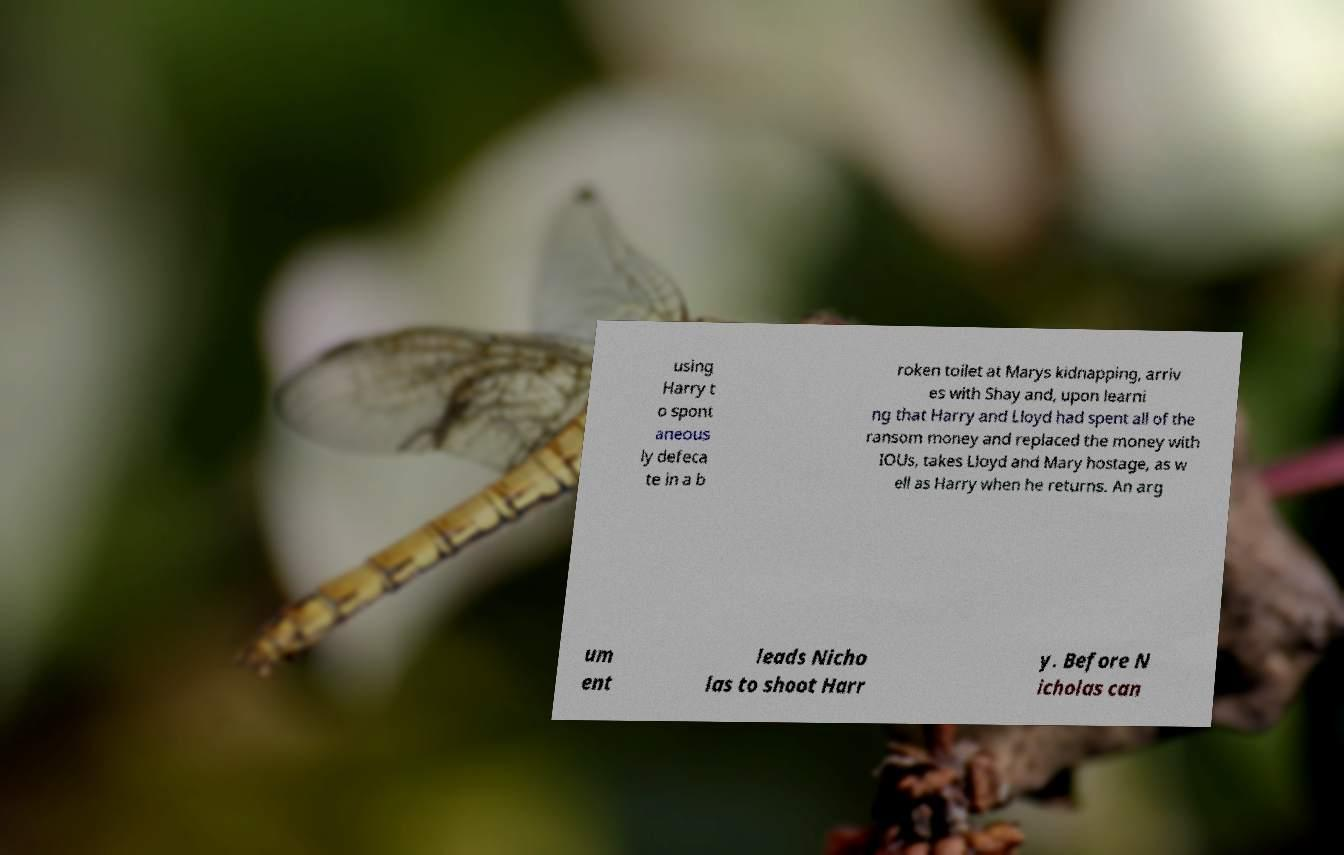Could you assist in decoding the text presented in this image and type it out clearly? using Harry t o spont aneous ly defeca te in a b roken toilet at Marys kidnapping, arriv es with Shay and, upon learni ng that Harry and Lloyd had spent all of the ransom money and replaced the money with IOUs, takes Lloyd and Mary hostage, as w ell as Harry when he returns. An arg um ent leads Nicho las to shoot Harr y. Before N icholas can 